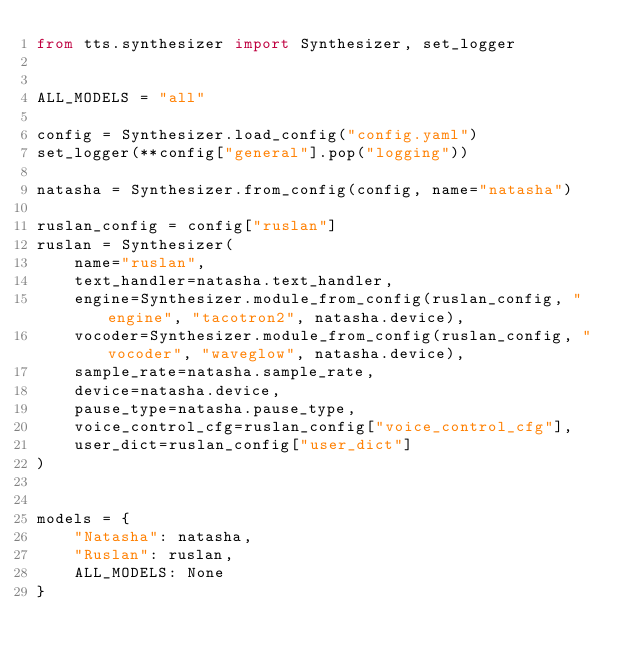Convert code to text. <code><loc_0><loc_0><loc_500><loc_500><_Python_>from tts.synthesizer import Synthesizer, set_logger


ALL_MODELS = "all"

config = Synthesizer.load_config("config.yaml")
set_logger(**config["general"].pop("logging"))

natasha = Synthesizer.from_config(config, name="natasha")

ruslan_config = config["ruslan"]
ruslan = Synthesizer(
    name="ruslan",
    text_handler=natasha.text_handler,
    engine=Synthesizer.module_from_config(ruslan_config, "engine", "tacotron2", natasha.device),
    vocoder=Synthesizer.module_from_config(ruslan_config, "vocoder", "waveglow", natasha.device),
    sample_rate=natasha.sample_rate,
    device=natasha.device,
    pause_type=natasha.pause_type,
    voice_control_cfg=ruslan_config["voice_control_cfg"],
    user_dict=ruslan_config["user_dict"]
)


models = {
    "Natasha": natasha,
    "Ruslan": ruslan,
    ALL_MODELS: None
}</code> 